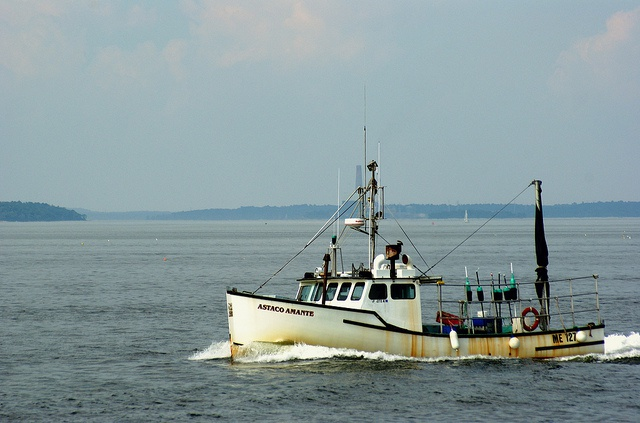Describe the objects in this image and their specific colors. I can see a boat in darkgray, black, gray, and beige tones in this image. 